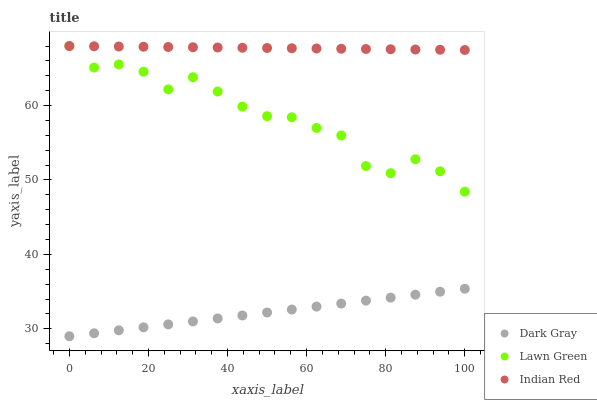Does Dark Gray have the minimum area under the curve?
Answer yes or no. Yes. Does Indian Red have the maximum area under the curve?
Answer yes or no. Yes. Does Lawn Green have the minimum area under the curve?
Answer yes or no. No. Does Lawn Green have the maximum area under the curve?
Answer yes or no. No. Is Dark Gray the smoothest?
Answer yes or no. Yes. Is Lawn Green the roughest?
Answer yes or no. Yes. Is Indian Red the smoothest?
Answer yes or no. No. Is Indian Red the roughest?
Answer yes or no. No. Does Dark Gray have the lowest value?
Answer yes or no. Yes. Does Lawn Green have the lowest value?
Answer yes or no. No. Does Indian Red have the highest value?
Answer yes or no. Yes. Is Dark Gray less than Lawn Green?
Answer yes or no. Yes. Is Indian Red greater than Dark Gray?
Answer yes or no. Yes. Does Indian Red intersect Lawn Green?
Answer yes or no. Yes. Is Indian Red less than Lawn Green?
Answer yes or no. No. Is Indian Red greater than Lawn Green?
Answer yes or no. No. Does Dark Gray intersect Lawn Green?
Answer yes or no. No. 